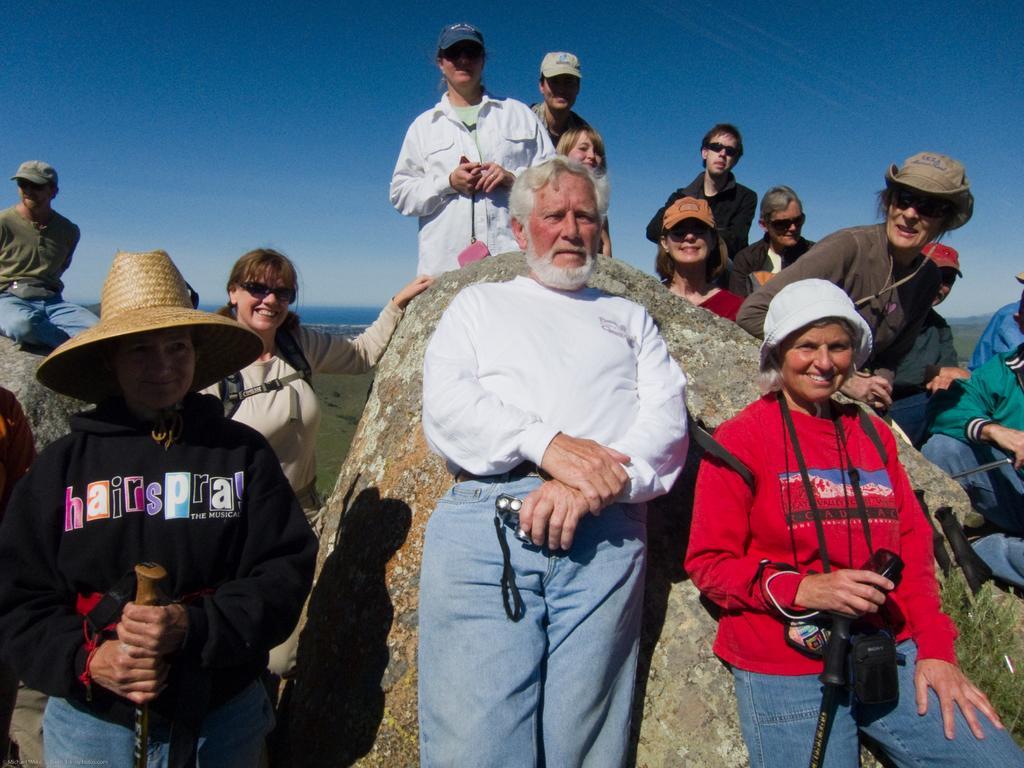How would you summarize this image in a sentence or two? In the foreground of the picture there are many people standing. In the foreground, in the center there is a man holding camera. On the left there is a woman holding stick. On the right there is a woman holding stick. Behind them there is a rock. Sky is clear and it is sunny. 